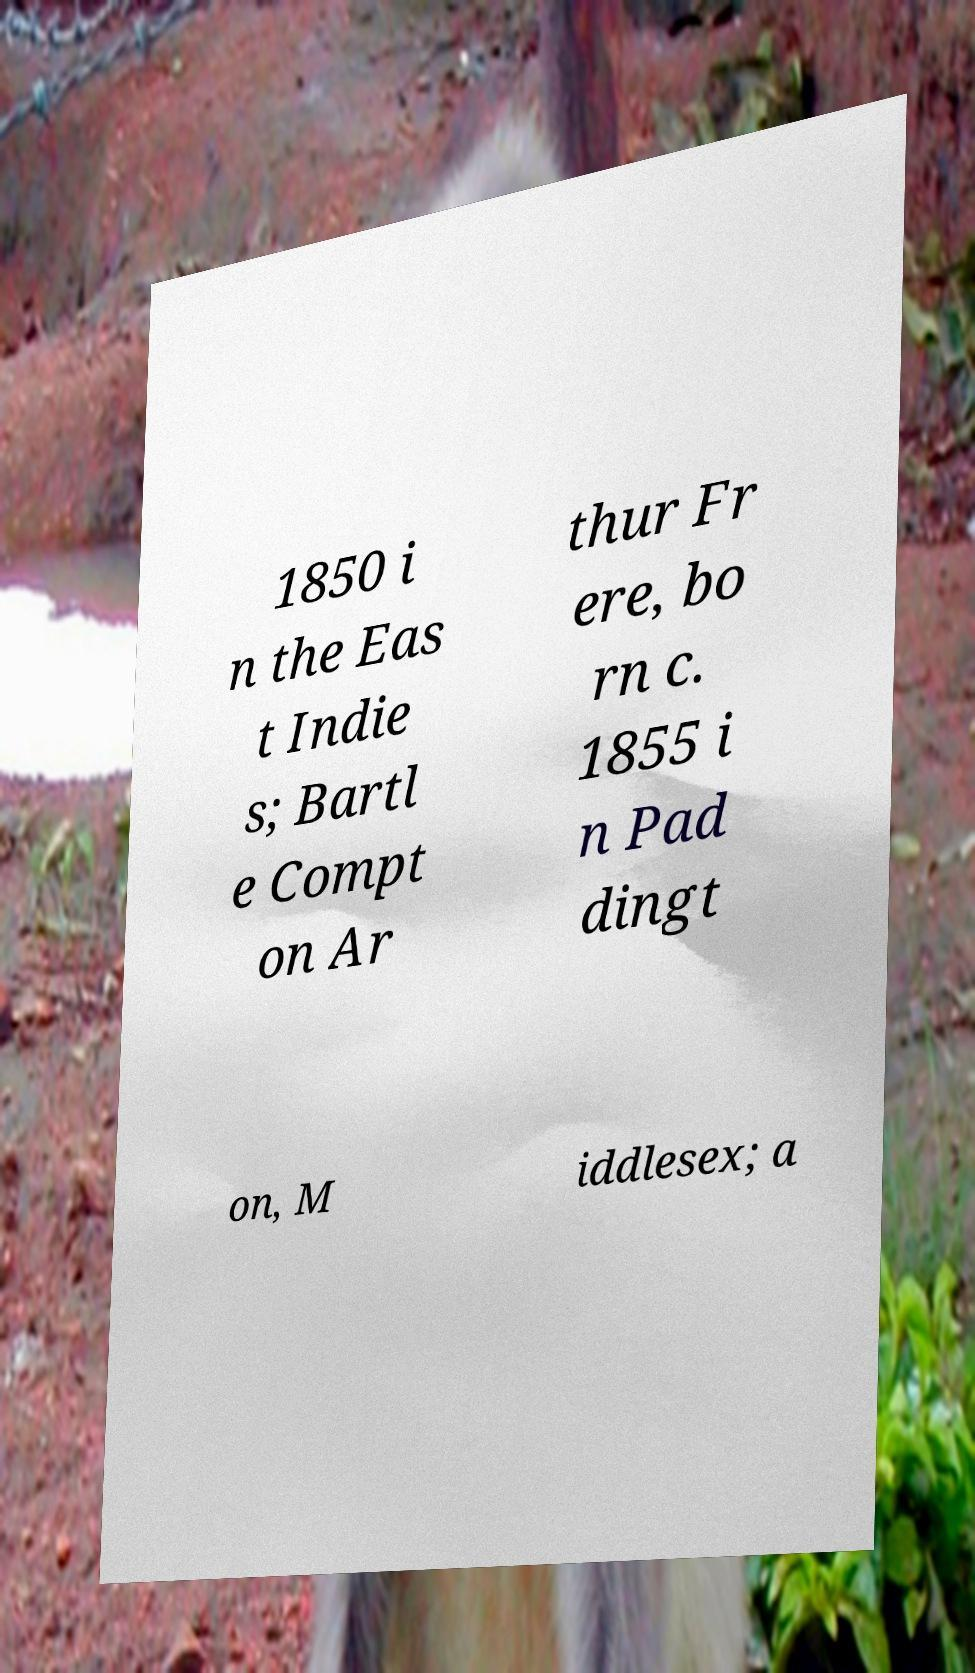Can you read and provide the text displayed in the image?This photo seems to have some interesting text. Can you extract and type it out for me? 1850 i n the Eas t Indie s; Bartl e Compt on Ar thur Fr ere, bo rn c. 1855 i n Pad dingt on, M iddlesex; a 